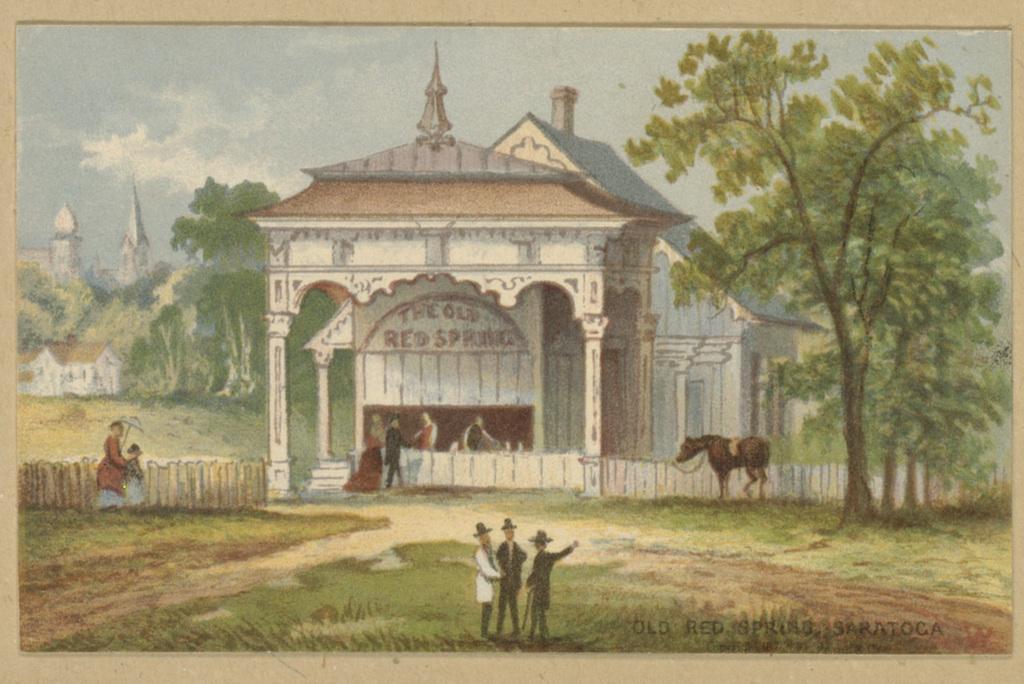Describe this image in one or two sentences. In the center of the image we can see the painting, in which we can see the sky, clouds, trees, buildings, grass, some text and one animal. 